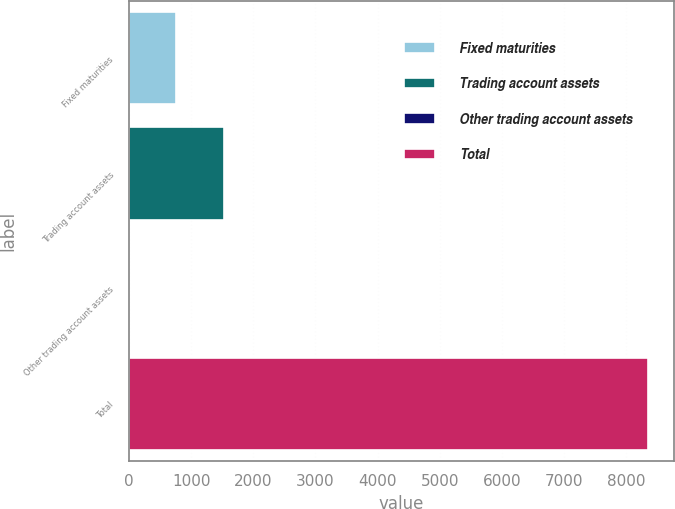Convert chart to OTSL. <chart><loc_0><loc_0><loc_500><loc_500><bar_chart><fcel>Fixed maturities<fcel>Trading account assets<fcel>Other trading account assets<fcel>Total<nl><fcel>763.19<fcel>1525.61<fcel>0.77<fcel>8343.42<nl></chart> 